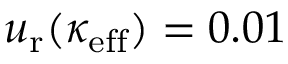<formula> <loc_0><loc_0><loc_500><loc_500>u _ { r } ( \kappa _ { e f f } ) = 0 . 0 1</formula> 